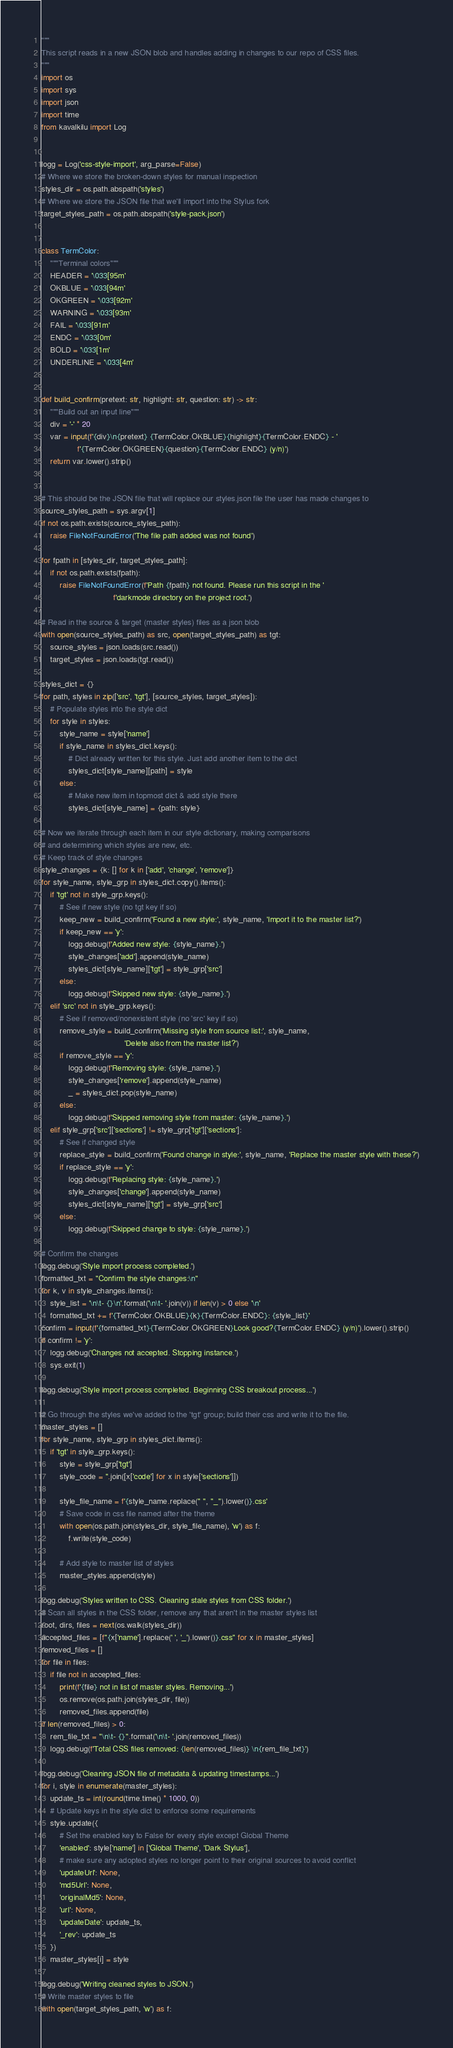Convert code to text. <code><loc_0><loc_0><loc_500><loc_500><_Python_>"""
This script reads in a new JSON blob and handles adding in changes to our repo of CSS files.
"""
import os
import sys
import json
import time
from kavalkilu import Log


logg = Log('css-style-import', arg_parse=False)
# Where we store the broken-down styles for manual inspection
styles_dir = os.path.abspath('styles')
# Where we store the JSON file that we'll import into the Stylus fork
target_styles_path = os.path.abspath('style-pack.json')


class TermColor:
    """Terminal colors"""
    HEADER = '\033[95m'
    OKBLUE = '\033[94m'
    OKGREEN = '\033[92m'
    WARNING = '\033[93m'
    FAIL = '\033[91m'
    ENDC = '\033[0m'
    BOLD = '\033[1m'
    UNDERLINE = '\033[4m'


def build_confirm(pretext: str, highlight: str, question: str) -> str:
    """Build out an input line"""
    div = '-' * 20
    var = input(f'{div}\n{pretext} {TermColor.OKBLUE}{highlight}{TermColor.ENDC} - '
                f'{TermColor.OKGREEN}{question}{TermColor.ENDC} (y/n)')
    return var.lower().strip()


# This should be the JSON file that will replace our styles.json file the user has made changes to
source_styles_path = sys.argv[1]
if not os.path.exists(source_styles_path):
    raise FileNotFoundError('The file path added was not found')

for fpath in [styles_dir, target_styles_path]:
    if not os.path.exists(fpath):
        raise FileNotFoundError(f'Path {fpath} not found. Please run this script in the '
                                f'darkmode directory on the project root.')

# Read in the source & target (master styles) files as a json blob
with open(source_styles_path) as src, open(target_styles_path) as tgt:
    source_styles = json.loads(src.read())
    target_styles = json.loads(tgt.read())

styles_dict = {}
for path, styles in zip(['src', 'tgt'], [source_styles, target_styles]):
    # Populate styles into the style dict
    for style in styles:
        style_name = style['name']
        if style_name in styles_dict.keys():
            # Dict already written for this style. Just add another item to the dict
            styles_dict[style_name][path] = style
        else:
            # Make new item in topmost dict & add style there
            styles_dict[style_name] = {path: style}

# Now we iterate through each item in our style dictionary, making comparisons
# and determining which styles are new, etc.
# Keep track of style changes
style_changes = {k: [] for k in ['add', 'change', 'remove']}
for style_name, style_grp in styles_dict.copy().items():
    if 'tgt' not in style_grp.keys():
        # See if new style (no tgt key if so)
        keep_new = build_confirm('Found a new style:', style_name, 'Import it to the master list?')
        if keep_new == 'y':
            logg.debug(f'Added new style: {style_name}.')
            style_changes['add'].append(style_name)
            styles_dict[style_name]['tgt'] = style_grp['src']
        else:
            logg.debug(f'Skipped new style: {style_name}.')
    elif 'src' not in style_grp.keys():
        # See if removed/nonexistent style (no 'src' key if so)
        remove_style = build_confirm('Missing style from source list:', style_name,
                                     'Delete also from the master list?')
        if remove_style == 'y':
            logg.debug(f'Removing style: {style_name}.')
            style_changes['remove'].append(style_name)
            _ = styles_dict.pop(style_name)
        else:
            logg.debug(f'Skipped removing style from master: {style_name}.')
    elif style_grp['src']['sections'] != style_grp['tgt']['sections']:
        # See if changed style
        replace_style = build_confirm('Found change in style:', style_name, 'Replace the master style with these?')
        if replace_style == 'y':
            logg.debug(f'Replacing style: {style_name}.')
            style_changes['change'].append(style_name)
            styles_dict[style_name]['tgt'] = style_grp['src']
        else:
            logg.debug(f'Skipped change to style: {style_name}.')

# Confirm the changes
logg.debug('Style import process completed.')
formatted_txt = "Confirm the style changes:\n"
for k, v in style_changes.items():
    style_list = '\n\t- {}\n'.format('\n\t- '.join(v)) if len(v) > 0 else '\n'
    formatted_txt += f'{TermColor.OKBLUE}{k}{TermColor.ENDC}: {style_list}'
confirm = input(f'{formatted_txt}{TermColor.OKGREEN}Look good?{TermColor.ENDC} (y/n)').lower().strip()
if confirm != 'y':
    logg.debug('Changes not accepted. Stopping instance.')
    sys.exit(1)

logg.debug('Style import process completed. Beginning CSS breakout process...')

# Go through the styles we've added to the 'tgt' group; build their css and write it to the file.
master_styles = []
for style_name, style_grp in styles_dict.items():
    if 'tgt' in style_grp.keys():
        style = style_grp['tgt']
        style_code = ''.join([x['code'] for x in style['sections']])

        style_file_name = f'{style_name.replace(" ", "_").lower()}.css'
        # Save code in css file named after the theme
        with open(os.path.join(styles_dir, style_file_name), 'w') as f:
            f.write(style_code)

        # Add style to master list of styles
        master_styles.append(style)

logg.debug('Styles written to CSS. Cleaning stale styles from CSS folder.')
# Scan all styles in the CSS folder, remove any that aren't in the master styles list
root, dirs, files = next(os.walk(styles_dir))
accepted_files = [f"{x['name'].replace(' ', '_').lower()}.css" for x in master_styles]
removed_files = []
for file in files:
    if file not in accepted_files:
        print(f'{file} not in list of master styles. Removing...')
        os.remove(os.path.join(styles_dir, file))
        removed_files.append(file)
if len(removed_files) > 0:
    rem_file_txt = "\n\t- {}".format('\n\t- '.join(removed_files))
    logg.debug(f'Total CSS files removed: {len(removed_files)} \n{rem_file_txt}')

logg.debug('Cleaning JSON file of metadata & updating timestamps...')
for i, style in enumerate(master_styles):
    update_ts = int(round(time.time() * 1000, 0))
    # Update keys in the style dict to enforce some requirements
    style.update({
        # Set the enabled key to False for every style except Global Theme
        'enabled': style['name'] in ['Global Theme', 'Dark Stylus'],
        # make sure any adopted styles no longer point to their original sources to avoid conflict
        'updateUrl': None,
        'md5Url': None,
        'originalMd5': None,
        'url': None,
        'updateDate': update_ts,
        '_rev': update_ts
    })
    master_styles[i] = style

logg.debug('Writing cleaned styles to JSON.')
# Write master styles to file
with open(target_styles_path, 'w') as f:</code> 